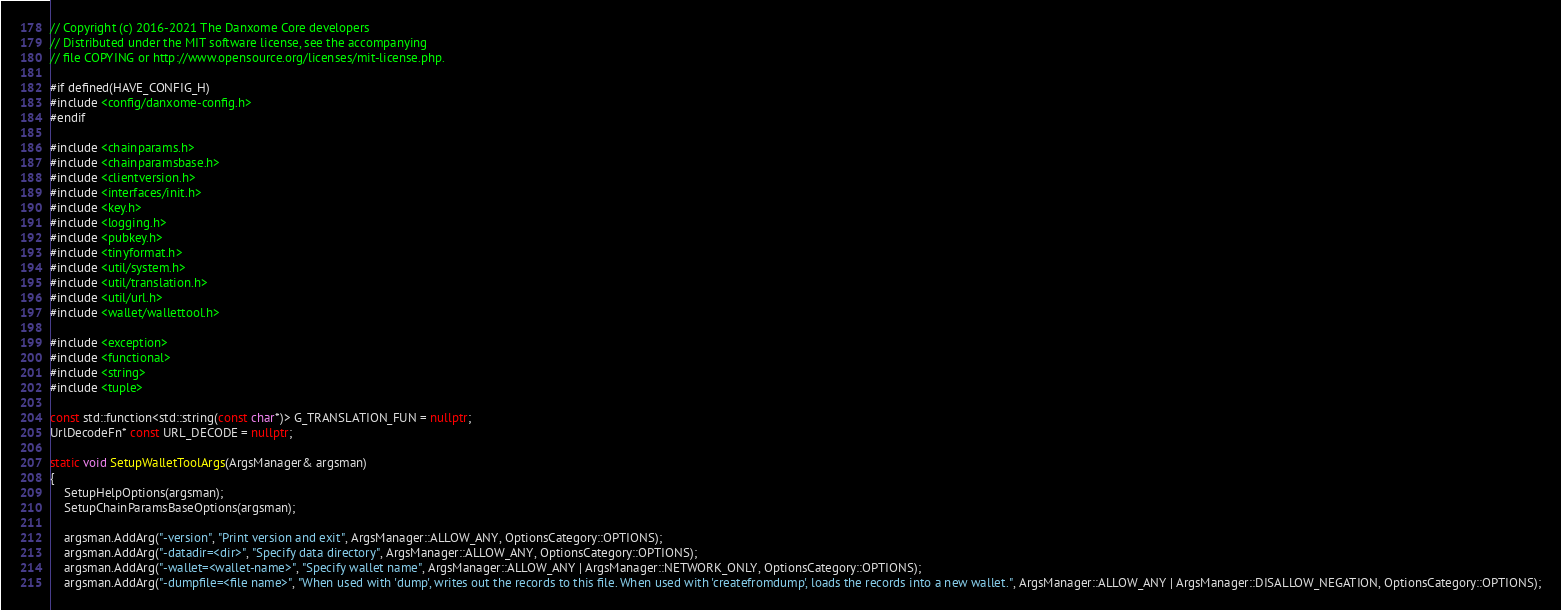<code> <loc_0><loc_0><loc_500><loc_500><_C++_>// Copyright (c) 2016-2021 The Danxome Core developers
// Distributed under the MIT software license, see the accompanying
// file COPYING or http://www.opensource.org/licenses/mit-license.php.

#if defined(HAVE_CONFIG_H)
#include <config/danxome-config.h>
#endif

#include <chainparams.h>
#include <chainparamsbase.h>
#include <clientversion.h>
#include <interfaces/init.h>
#include <key.h>
#include <logging.h>
#include <pubkey.h>
#include <tinyformat.h>
#include <util/system.h>
#include <util/translation.h>
#include <util/url.h>
#include <wallet/wallettool.h>

#include <exception>
#include <functional>
#include <string>
#include <tuple>

const std::function<std::string(const char*)> G_TRANSLATION_FUN = nullptr;
UrlDecodeFn* const URL_DECODE = nullptr;

static void SetupWalletToolArgs(ArgsManager& argsman)
{
    SetupHelpOptions(argsman);
    SetupChainParamsBaseOptions(argsman);

    argsman.AddArg("-version", "Print version and exit", ArgsManager::ALLOW_ANY, OptionsCategory::OPTIONS);
    argsman.AddArg("-datadir=<dir>", "Specify data directory", ArgsManager::ALLOW_ANY, OptionsCategory::OPTIONS);
    argsman.AddArg("-wallet=<wallet-name>", "Specify wallet name", ArgsManager::ALLOW_ANY | ArgsManager::NETWORK_ONLY, OptionsCategory::OPTIONS);
    argsman.AddArg("-dumpfile=<file name>", "When used with 'dump', writes out the records to this file. When used with 'createfromdump', loads the records into a new wallet.", ArgsManager::ALLOW_ANY | ArgsManager::DISALLOW_NEGATION, OptionsCategory::OPTIONS);</code> 